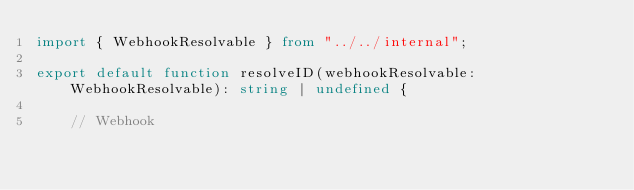Convert code to text. <code><loc_0><loc_0><loc_500><loc_500><_TypeScript_>import { WebhookResolvable } from "../../internal";

export default function resolveID(webhookResolvable: WebhookResolvable): string | undefined {

    // Webhook</code> 